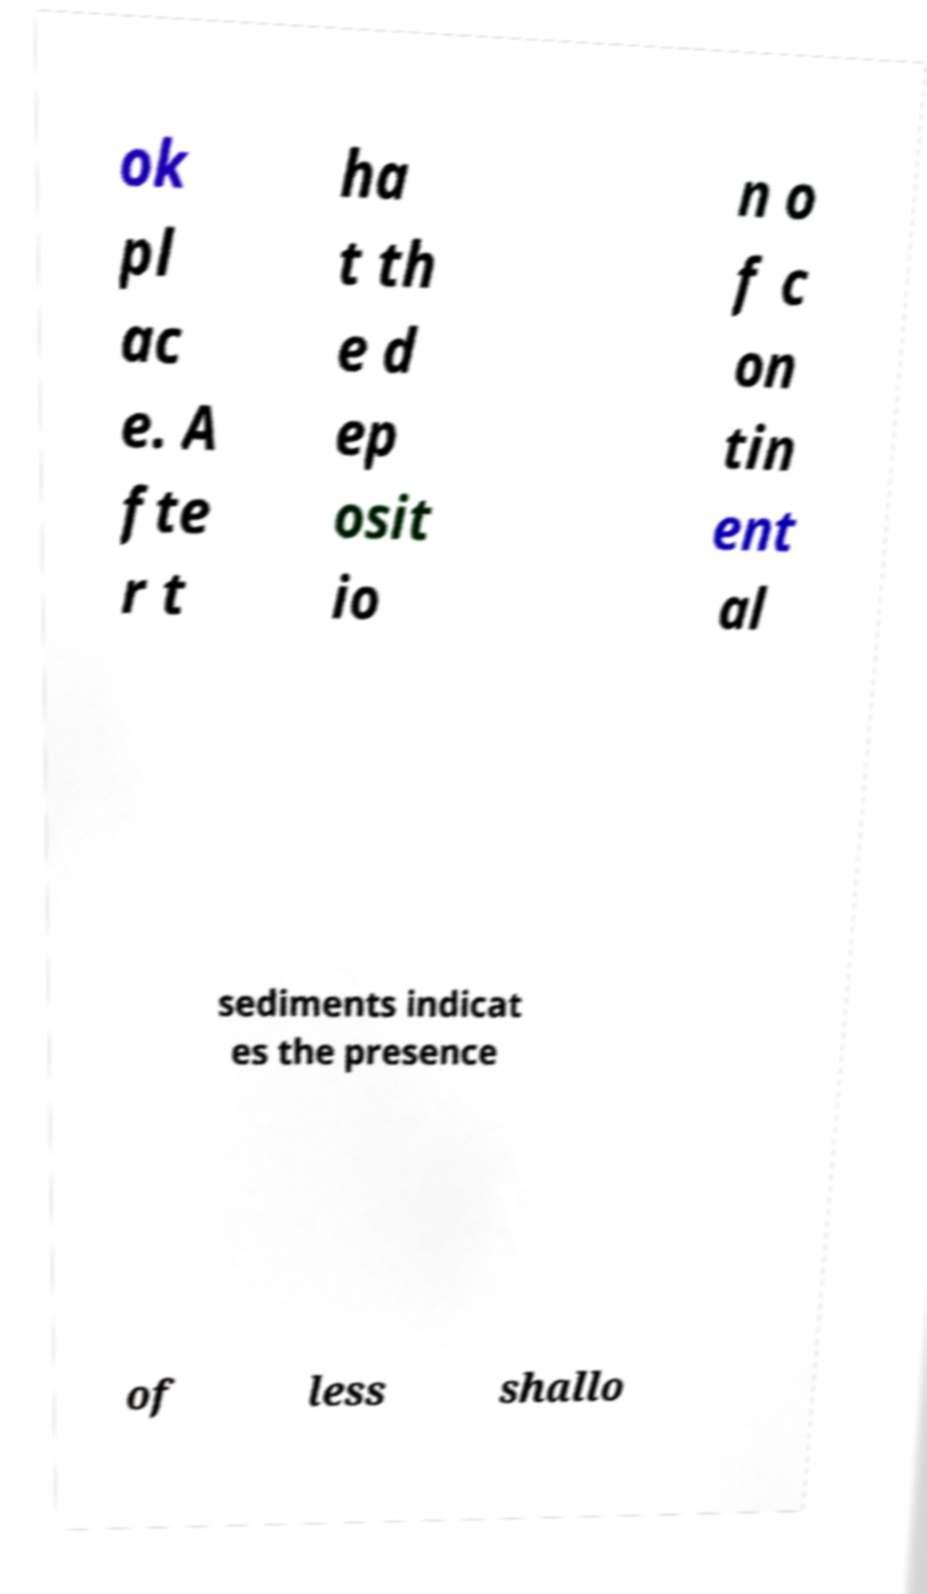Please read and relay the text visible in this image. What does it say? ok pl ac e. A fte r t ha t th e d ep osit io n o f c on tin ent al sediments indicat es the presence of less shallo 